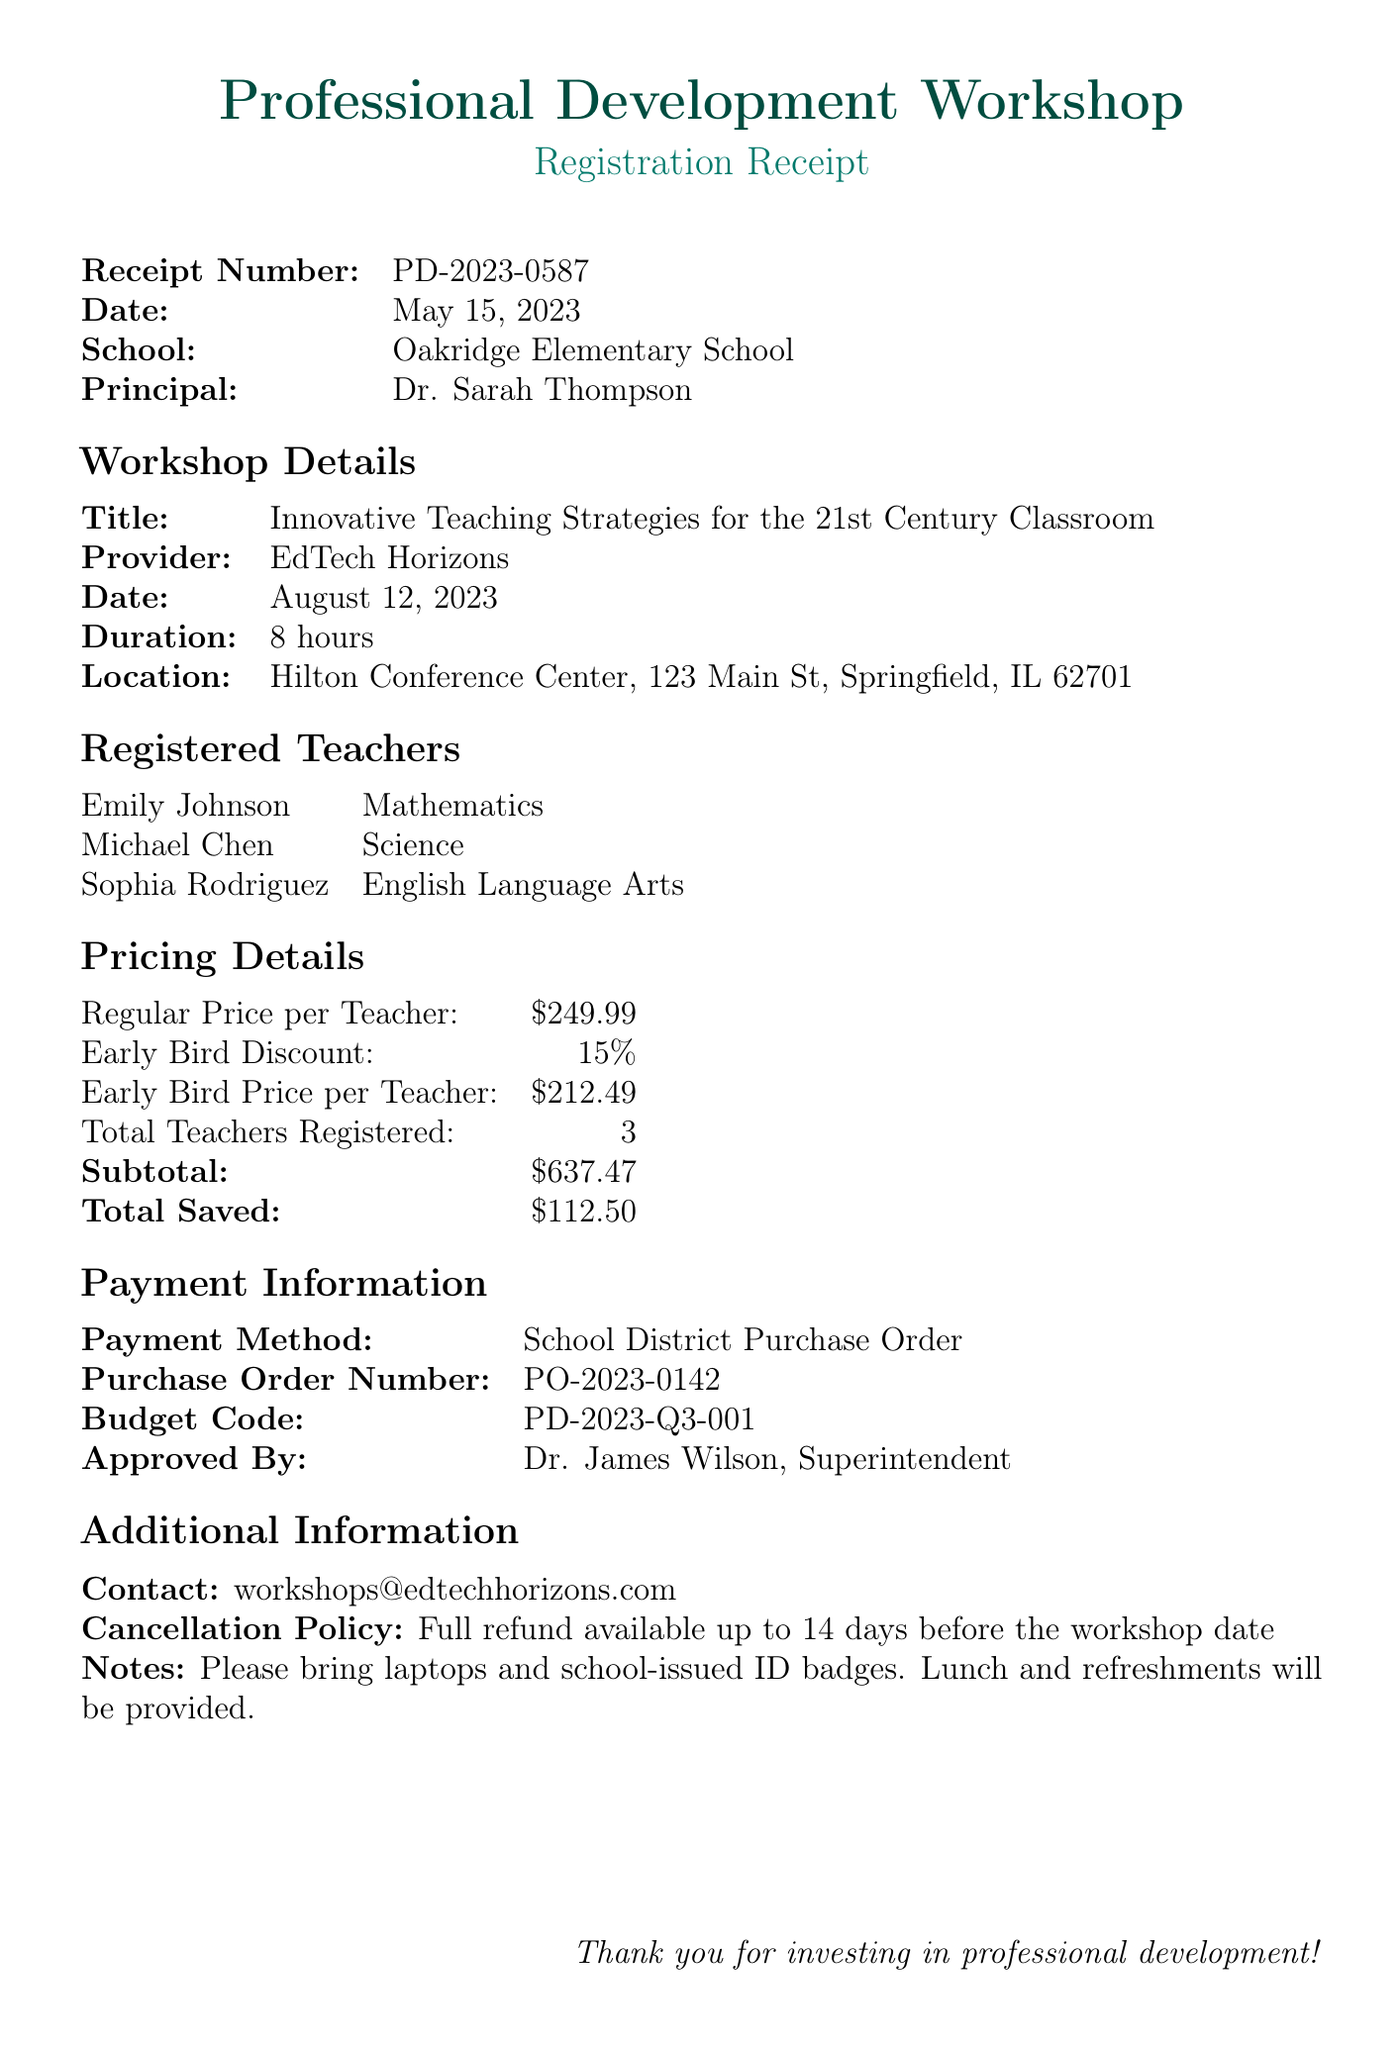What is the receipt number? The receipt number is explicitly stated in the document, which is PD-2023-0587.
Answer: PD-2023-0587 What is the date of the workshop? The date of the workshop is mentioned in the document and is August 12, 2023.
Answer: August 12, 2023 What is the total amount saved due to the early bird discount? The total saved amount is explicitly listed in the document, which is $112.50.
Answer: $112.50 How many teachers are registered for the workshop? The document states that a total of 3 teachers are registered for the workshop.
Answer: 3 What is the name of the workshop provider? The workshop provider's name is mentioned in the document as EdTech Horizons.
Answer: EdTech Horizons What is the location of the workshop? The location is provided in the document as Hilton Conference Center, 123 Main St, Springfield, IL 62701.
Answer: Hilton Conference Center, 123 Main St, Springfield, IL 62701 What is the early bird price per teacher? The early bird price is specifically mentioned in the document as $212.49.
Answer: $212.49 How long is the duration of the workshop? The duration of the workshop is stated as 8 hours in the document.
Answer: 8 hours What is the cancellation policy? The document specifies that a full refund is available up to 14 days before the workshop date.
Answer: Full refund available up to 14 days before the workshop date 